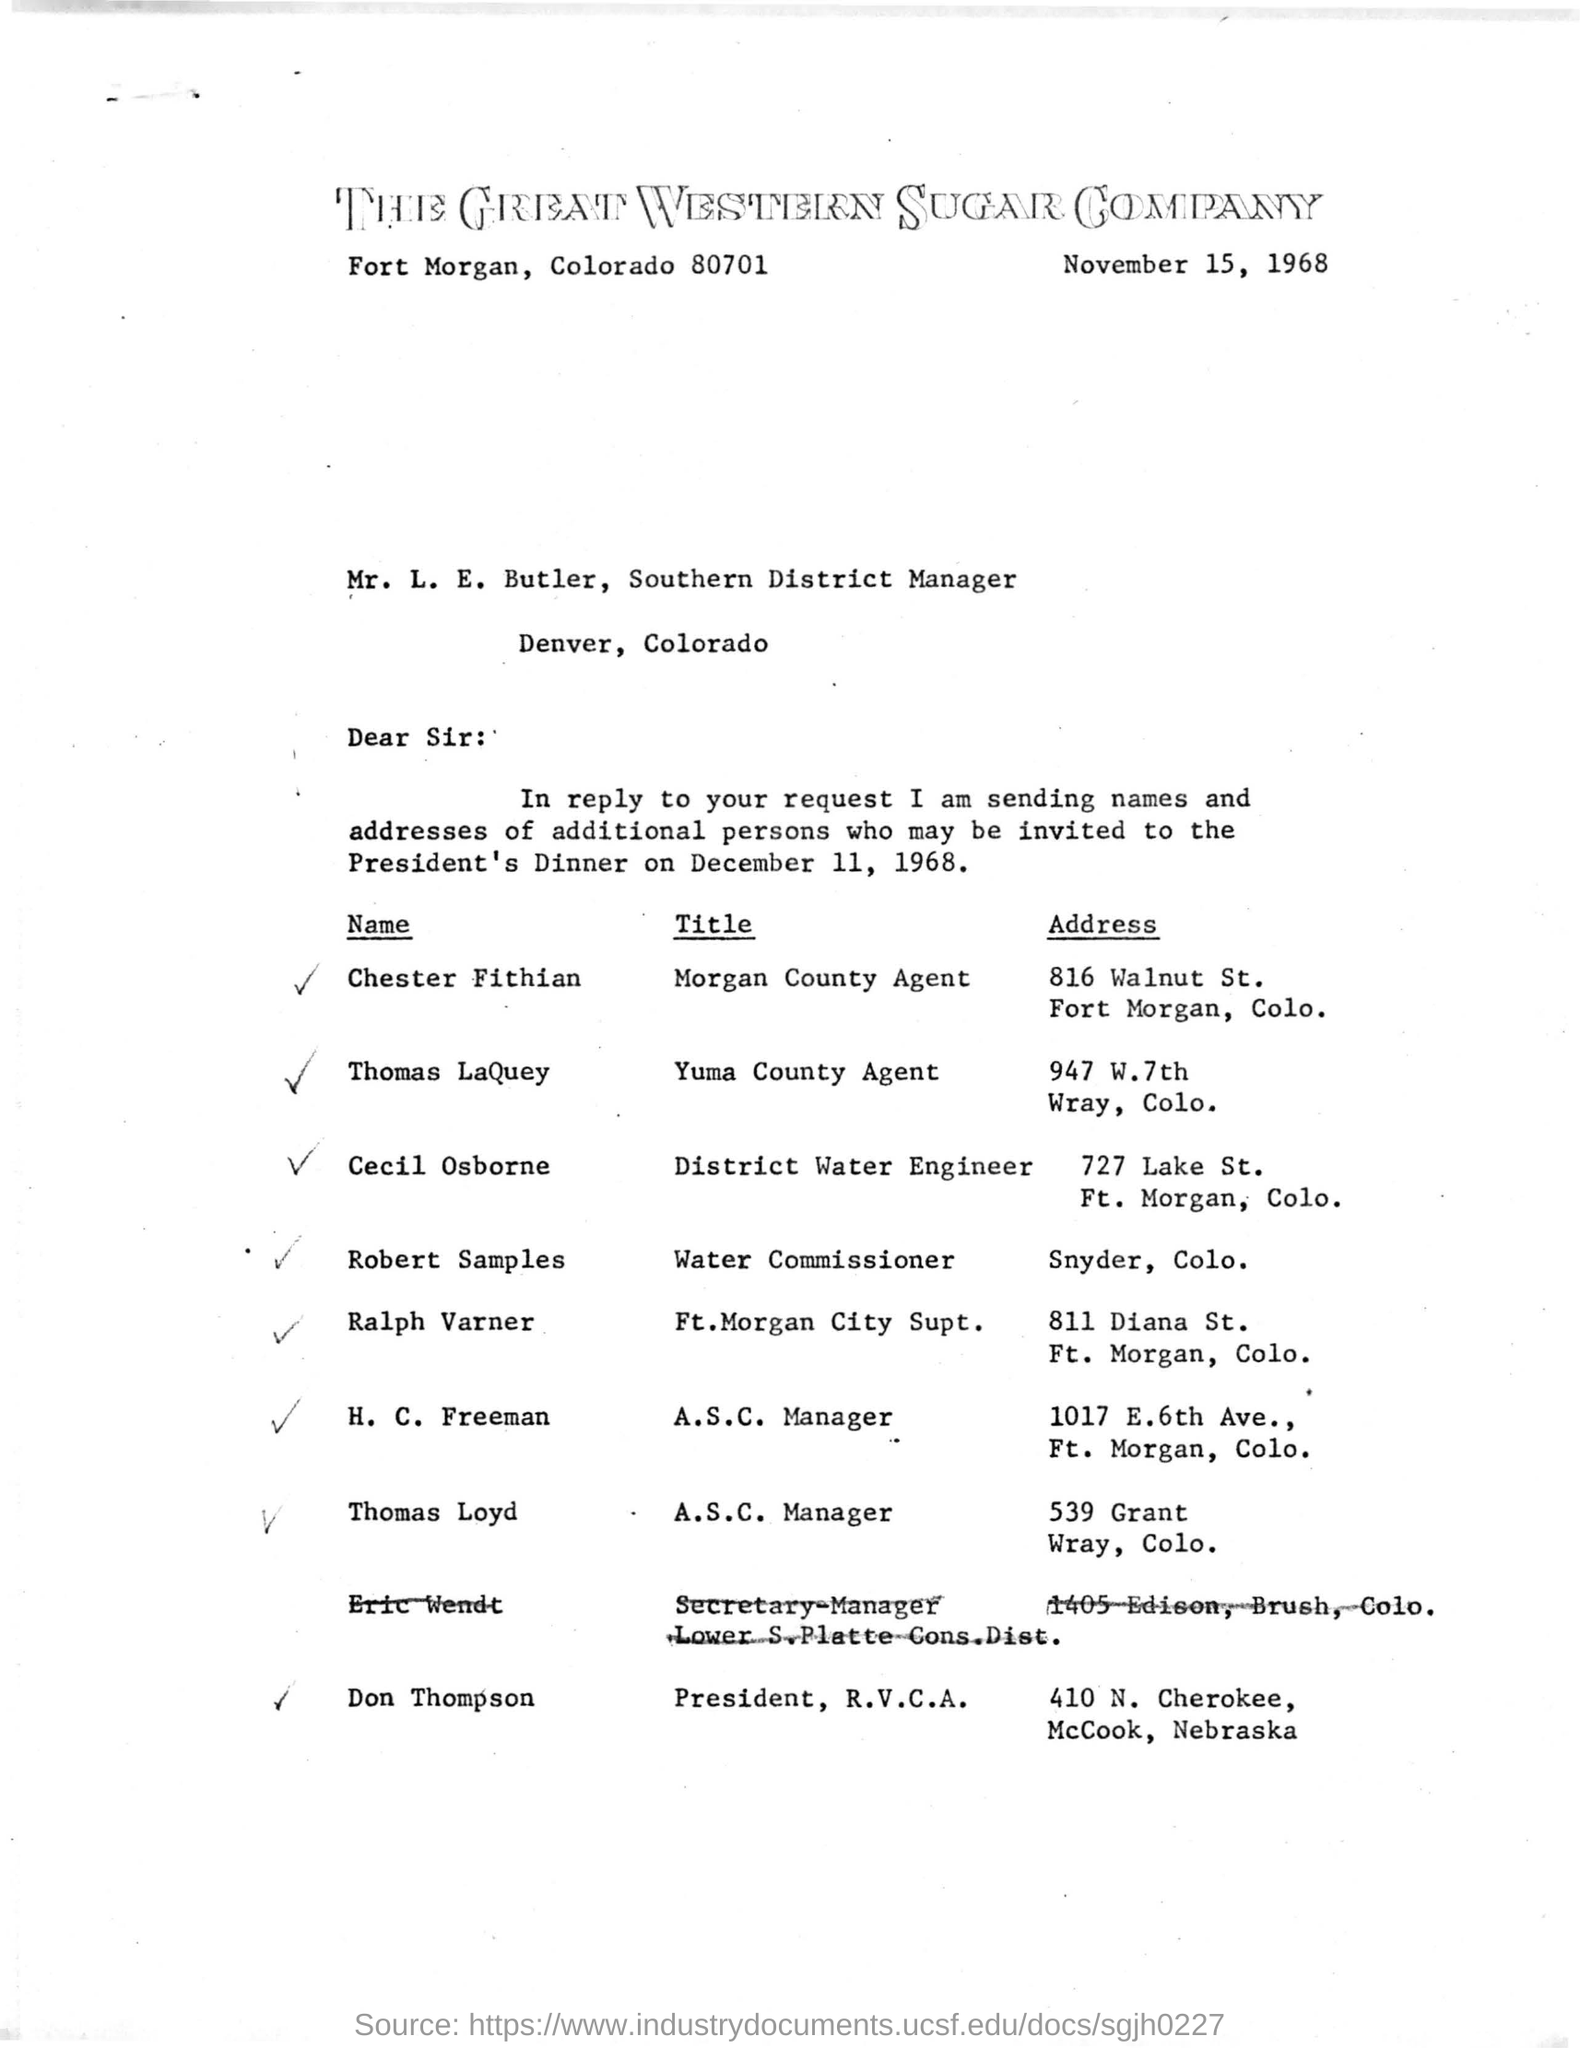When is the president's dinner?
Provide a succinct answer. December 11, 1968. Who is Chester Fithian?
Make the answer very short. Morgan county agent. 